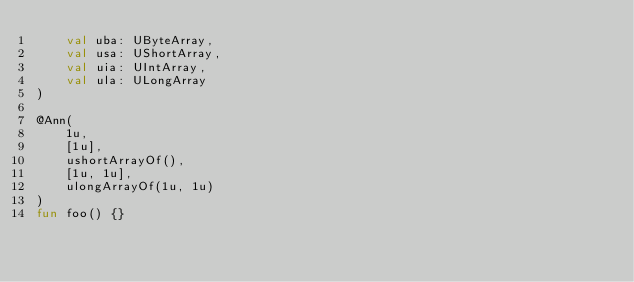<code> <loc_0><loc_0><loc_500><loc_500><_Kotlin_>    val uba: UByteArray,
    val usa: UShortArray,
    val uia: UIntArray,
    val ula: ULongArray
)

@Ann(
    1u,
    [1u],
    ushortArrayOf(),
    [1u, 1u],
    ulongArrayOf(1u, 1u)
)
fun foo() {}</code> 